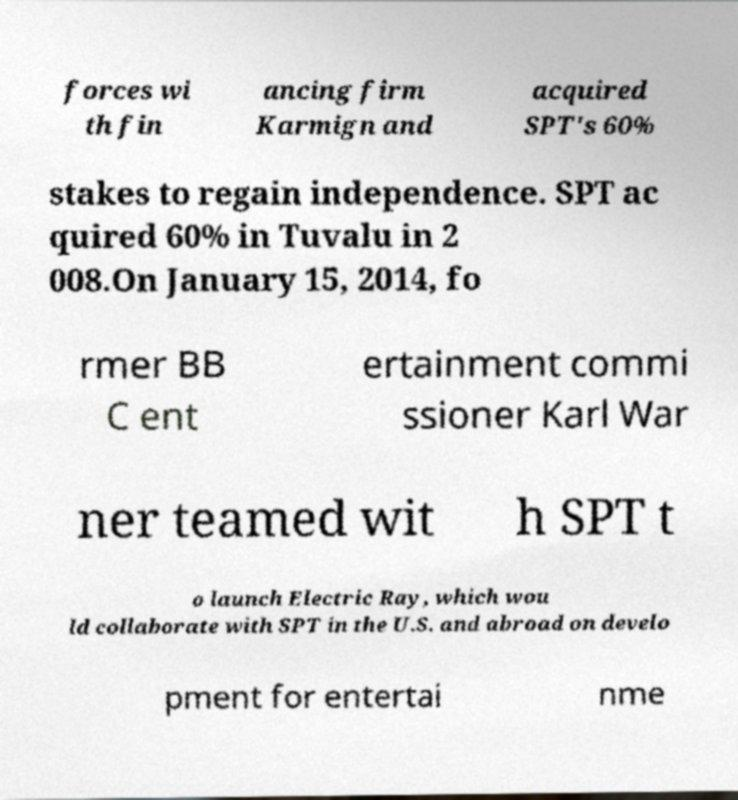Could you extract and type out the text from this image? forces wi th fin ancing firm Karmign and acquired SPT's 60% stakes to regain independence. SPT ac quired 60% in Tuvalu in 2 008.On January 15, 2014, fo rmer BB C ent ertainment commi ssioner Karl War ner teamed wit h SPT t o launch Electric Ray, which wou ld collaborate with SPT in the U.S. and abroad on develo pment for entertai nme 